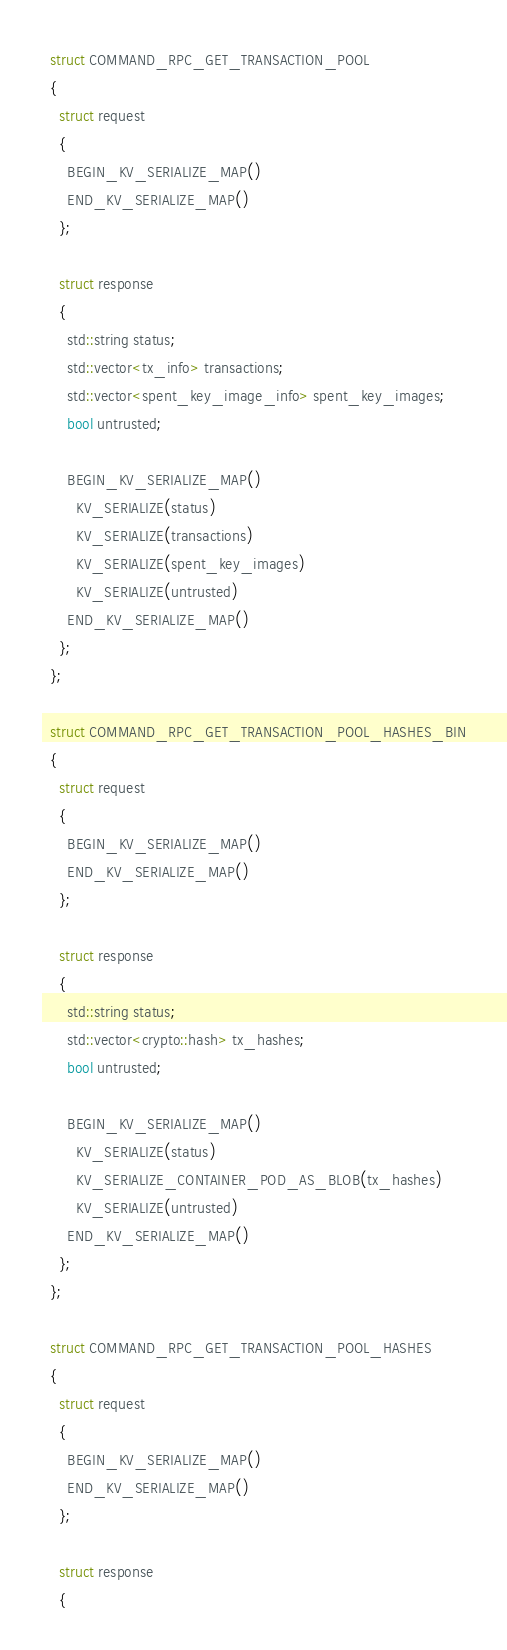Convert code to text. <code><loc_0><loc_0><loc_500><loc_500><_C_>  struct COMMAND_RPC_GET_TRANSACTION_POOL
  {
    struct request
    {
      BEGIN_KV_SERIALIZE_MAP()
      END_KV_SERIALIZE_MAP()
    };

    struct response
    {
      std::string status;
      std::vector<tx_info> transactions;
      std::vector<spent_key_image_info> spent_key_images;
      bool untrusted;

      BEGIN_KV_SERIALIZE_MAP()
        KV_SERIALIZE(status)
        KV_SERIALIZE(transactions)
        KV_SERIALIZE(spent_key_images)
        KV_SERIALIZE(untrusted)
      END_KV_SERIALIZE_MAP()
    };
  };

  struct COMMAND_RPC_GET_TRANSACTION_POOL_HASHES_BIN
  {
    struct request
    {
      BEGIN_KV_SERIALIZE_MAP()
      END_KV_SERIALIZE_MAP()
    };

    struct response
    {
      std::string status;
      std::vector<crypto::hash> tx_hashes;
      bool untrusted;

      BEGIN_KV_SERIALIZE_MAP()
        KV_SERIALIZE(status)
        KV_SERIALIZE_CONTAINER_POD_AS_BLOB(tx_hashes)
        KV_SERIALIZE(untrusted)
      END_KV_SERIALIZE_MAP()
    };
  };

  struct COMMAND_RPC_GET_TRANSACTION_POOL_HASHES
  {
    struct request
    {
      BEGIN_KV_SERIALIZE_MAP()
      END_KV_SERIALIZE_MAP()
    };

    struct response
    {</code> 